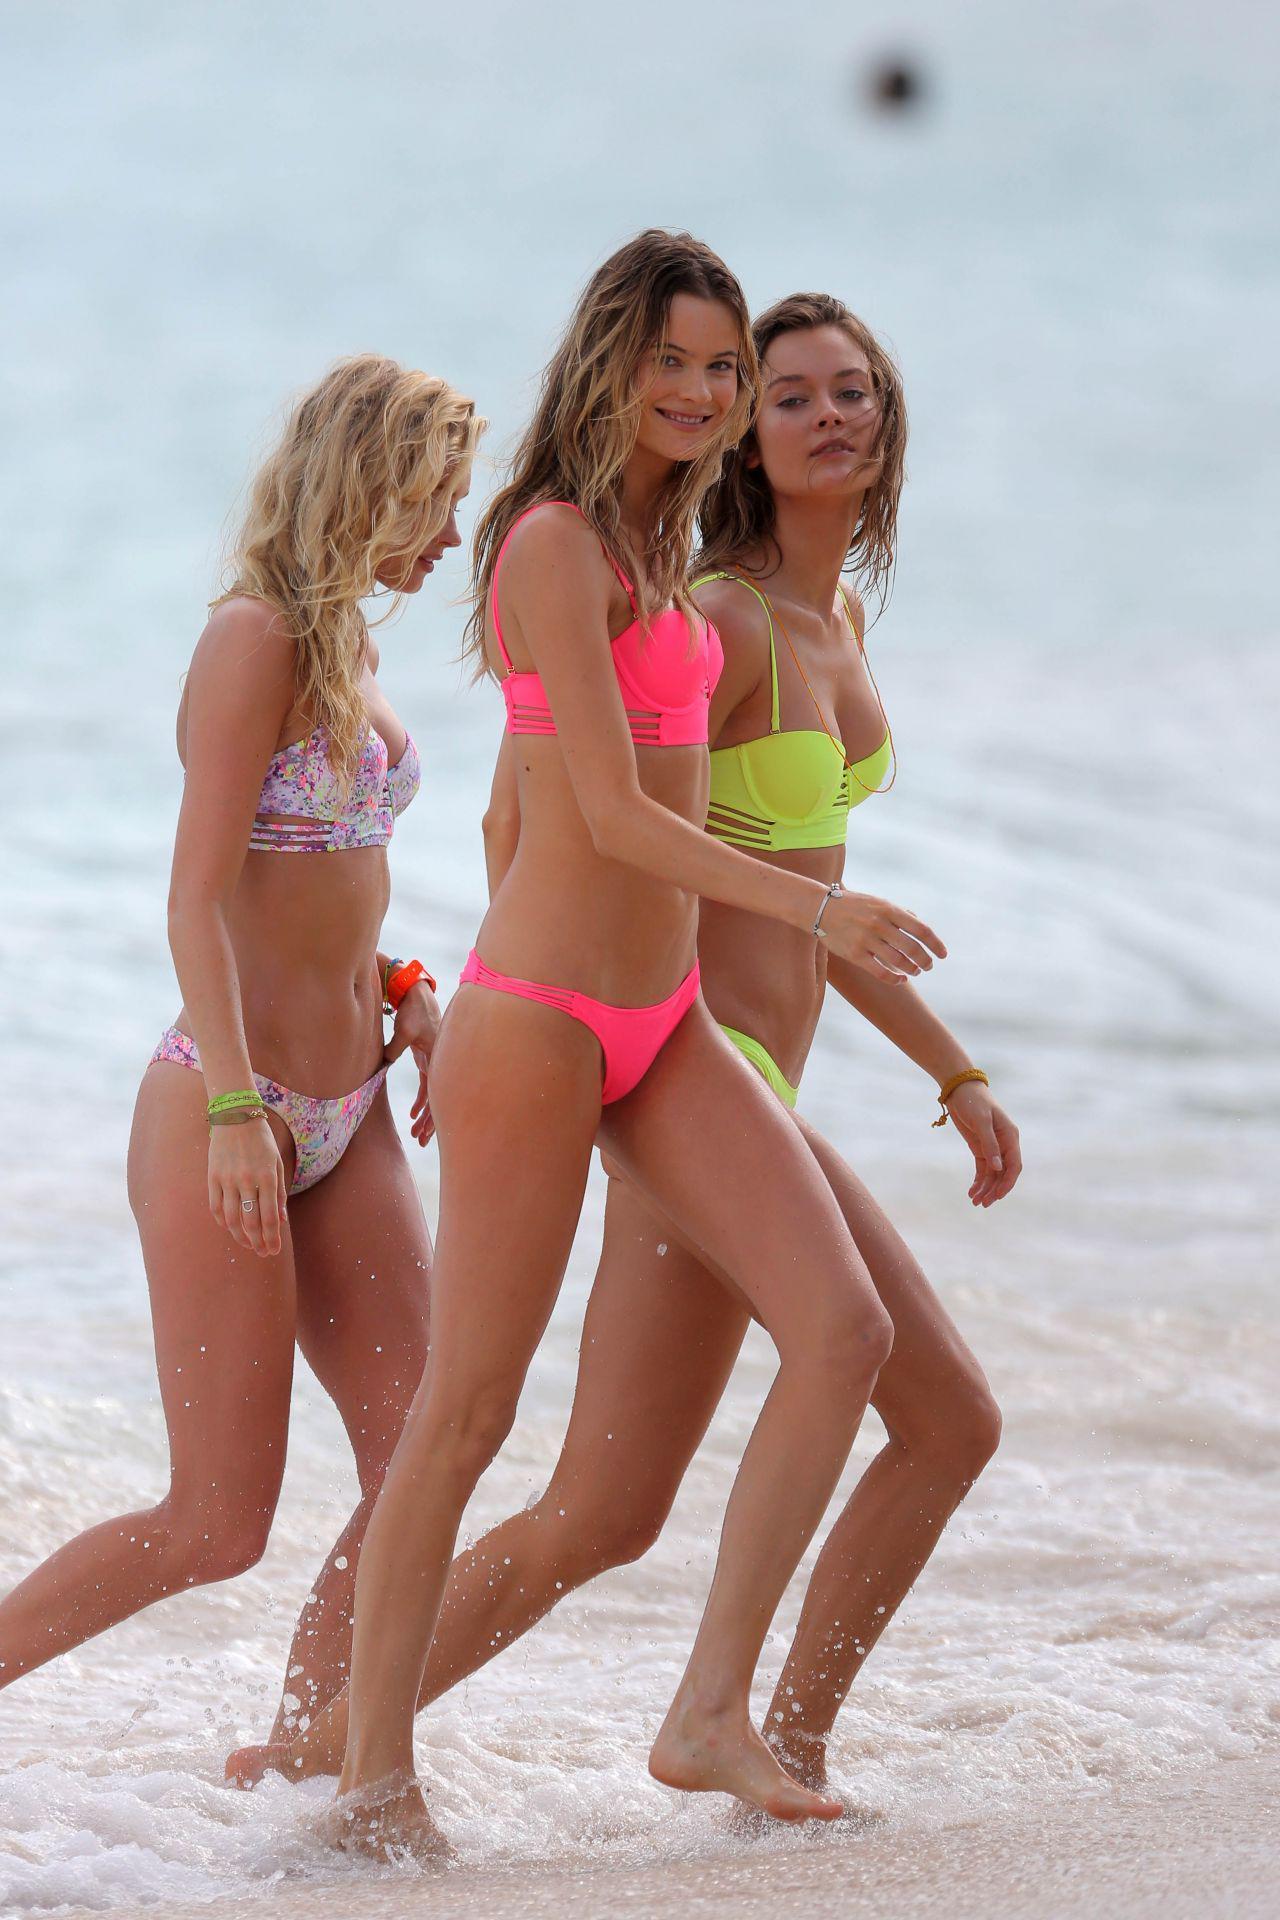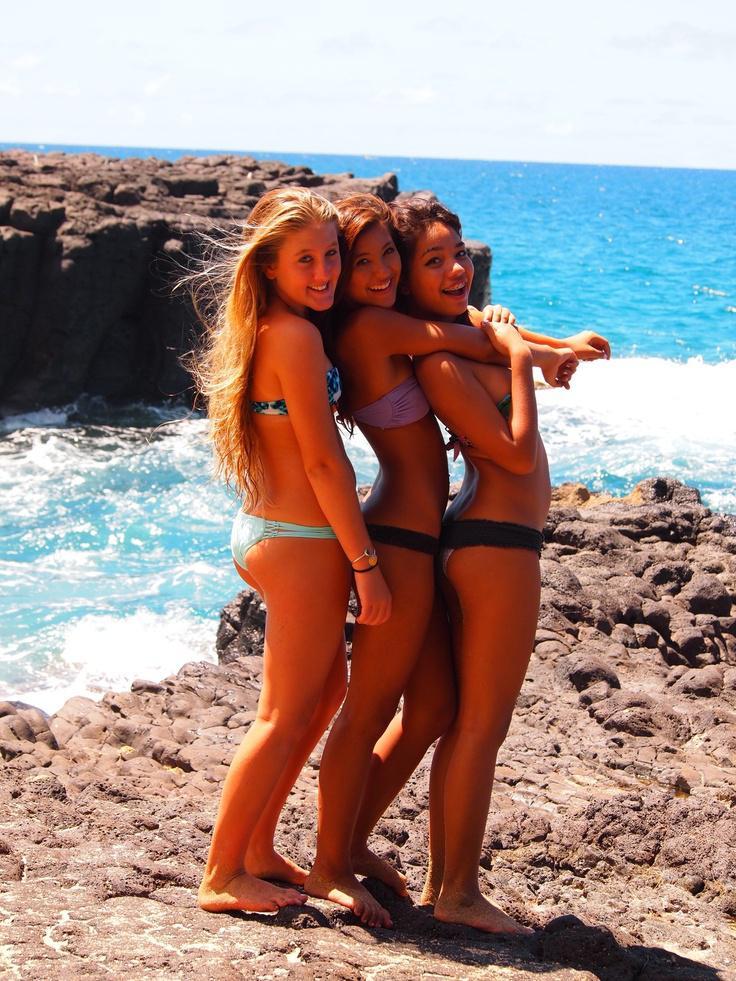The first image is the image on the left, the second image is the image on the right. Analyze the images presented: Is the assertion "Three girls stand side-by-side in bikini tops, and all wear the same color bottoms." valid? Answer yes or no. No. The first image is the image on the left, the second image is the image on the right. Given the left and right images, does the statement "One of the women is wearing a bright pink two piece bikini." hold true? Answer yes or no. Yes. 